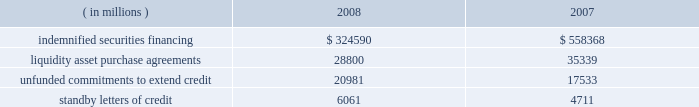The table summarizes the total contractual amount of credit-related , off-balance sheet financial instruments at december 31 .
Amounts reported do not reflect participations to independent third parties. .
Approximately 81% ( 81 % ) of the unfunded commitments to extend credit expire within one year from the date of issue .
Since many of the commitments are expected to expire or renew without being drawn upon , the total commitment amounts do not necessarily represent future cash requirements .
Securities finance : on behalf of our customers , we lend their securities to creditworthy brokers and other institutions .
We generally indemnify our customers for the fair market value of those securities against a failure of the borrower to return such securities .
Collateral funds received in connection with our securities finance services are held by us as agent and are not recorded in our consolidated statement of condition .
We require the borrowers to provide collateral in an amount equal to or in excess of 100% ( 100 % ) of the fair market value of the securities borrowed .
The borrowed securities are revalued daily to determine if additional collateral is necessary .
In this regard , we held , as agent , cash and u.s .
Government securities with an aggregate fair value of $ 333.07 billion and $ 572.93 billion as collateral for indemnified securities on loan at december 31 , 2008 and 2007 , respectively , presented in the table above .
The collateral held by us is invested on behalf of our customers .
In certain cases , the collateral is invested in third-party repurchase agreements , for which we indemnify the customer against loss of the principal invested .
We require the repurchase agreement counterparty to provide collateral in an amount equal to or in excess of 100% ( 100 % ) of the amount of the repurchase agreement .
The indemnified repurchase agreements and the related collateral are not recorded in our consolidated statement of condition .
Of the collateral of $ 333.07 billion at december 31 , 2008 and $ 572.93 billion at december 31 , 2007 referenced above , $ 68.37 billion at december 31 , 2008 and $ 106.13 billion at december 31 , 2007 was invested in indemnified repurchase agreements .
We held , as agent , cash and securities with an aggregate fair value of $ 71.87 billion and $ 111.02 billion as collateral for indemnified investments in repurchase agreements at december 31 , 2008 and december 31 , 2007 , respectively .
Asset-backed commercial paper program : in the normal course of our business , we provide liquidity and credit enhancement to an asset-backed commercial paper program sponsored and administered by us , described in note 12 .
The commercial paper issuances and commitments of the commercial paper conduits to provide funding are supported by liquidity asset purchase agreements and back-up liquidity lines of credit , the majority of which are provided by us .
In addition , we provide direct credit support to the conduits in the form of standby letters of credit .
Our commitments under liquidity asset purchase agreements and back-up lines of credit totaled $ 23.59 billion at december 31 , 2008 , and are included in the preceding table .
Our commitments under standby letters of credit totaled $ 1.00 billion at december 31 , 2008 , and are also included in the preceding table .
Legal proceedings : several customers have filed litigation claims against us , some of which are putative class actions purportedly on behalf of customers invested in certain of state street global advisors 2019 , or ssga 2019s , active fixed-income strategies .
These claims related to investment losses in one or more of ssga 2019s strategies that included sub-prime investments .
In 2007 , we established a reserve of approximately $ 625 million to address legal exposure associated with the under-performance of certain active fixed-income strategies managed by ssga and customer concerns as to whether the execution of these strategies was consistent with the customers 2019 investment intent .
These strategies were adversely impacted by exposure to , and the lack of liquidity in .
Between 2007 and 2008 , what percent did the value of standby letters of credit increase? 
Computations: ((6061 - 4711) / 4711)
Answer: 0.28656. 